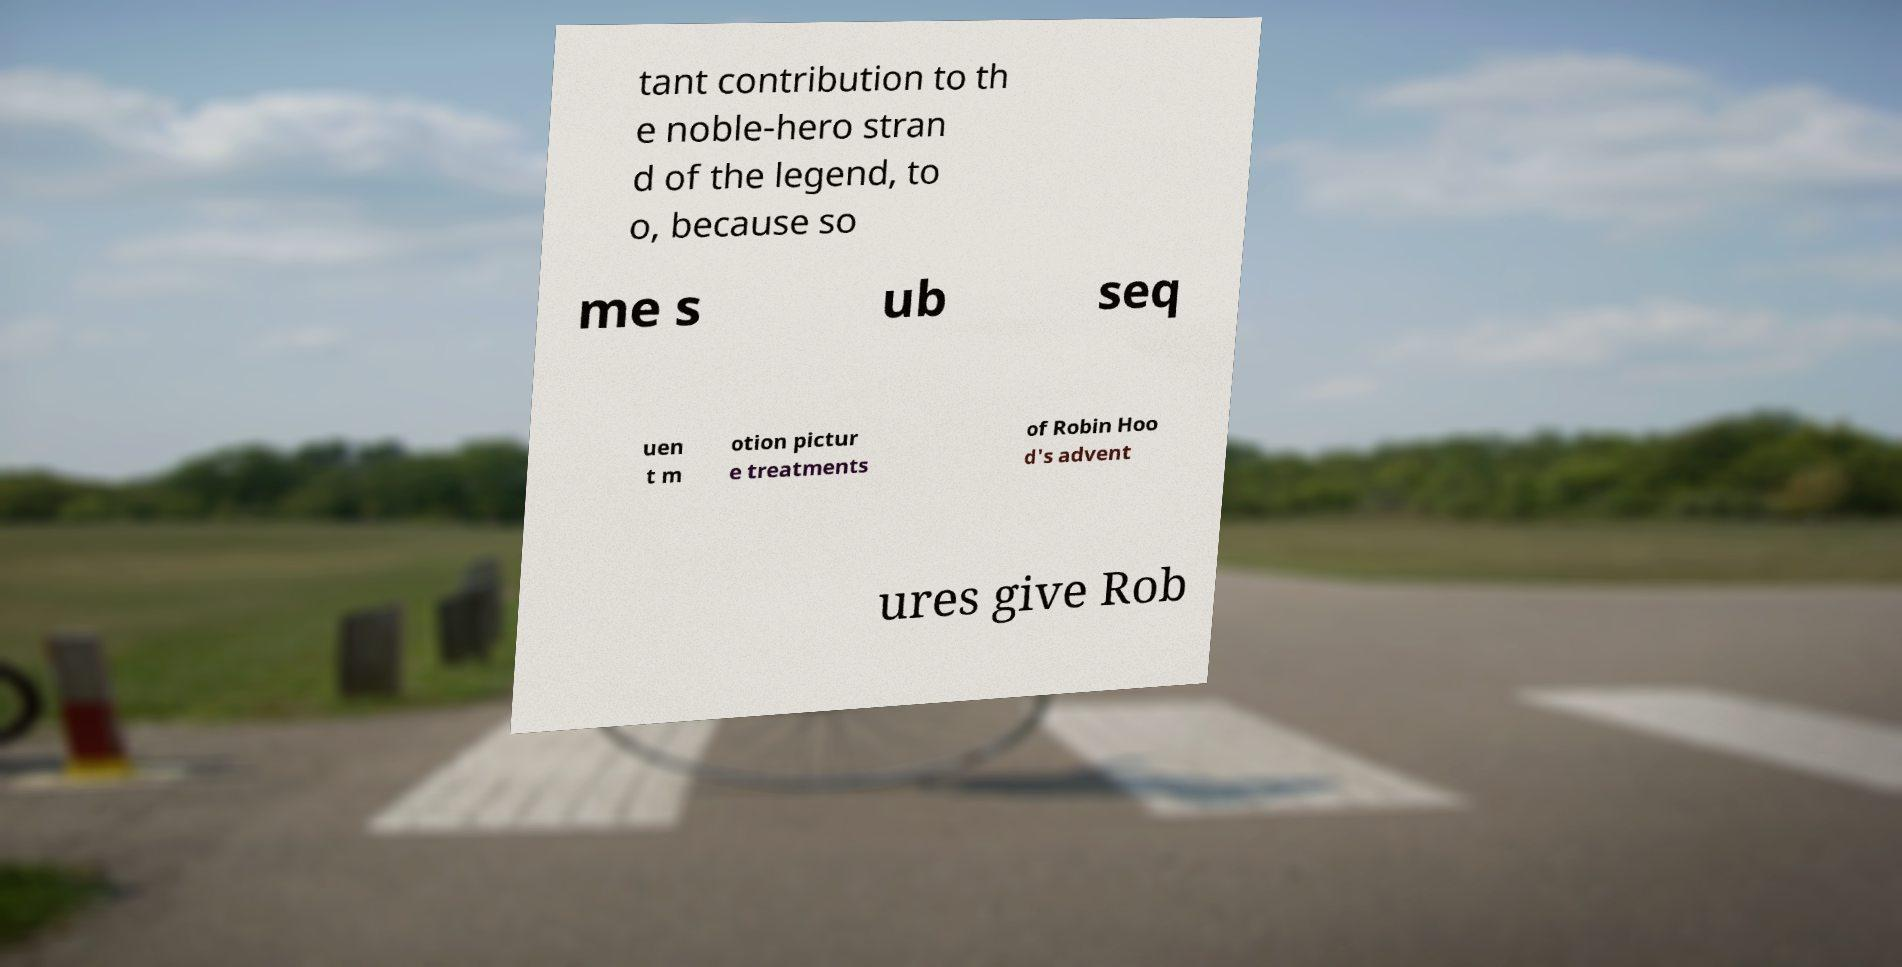For documentation purposes, I need the text within this image transcribed. Could you provide that? tant contribution to th e noble-hero stran d of the legend, to o, because so me s ub seq uen t m otion pictur e treatments of Robin Hoo d's advent ures give Rob 